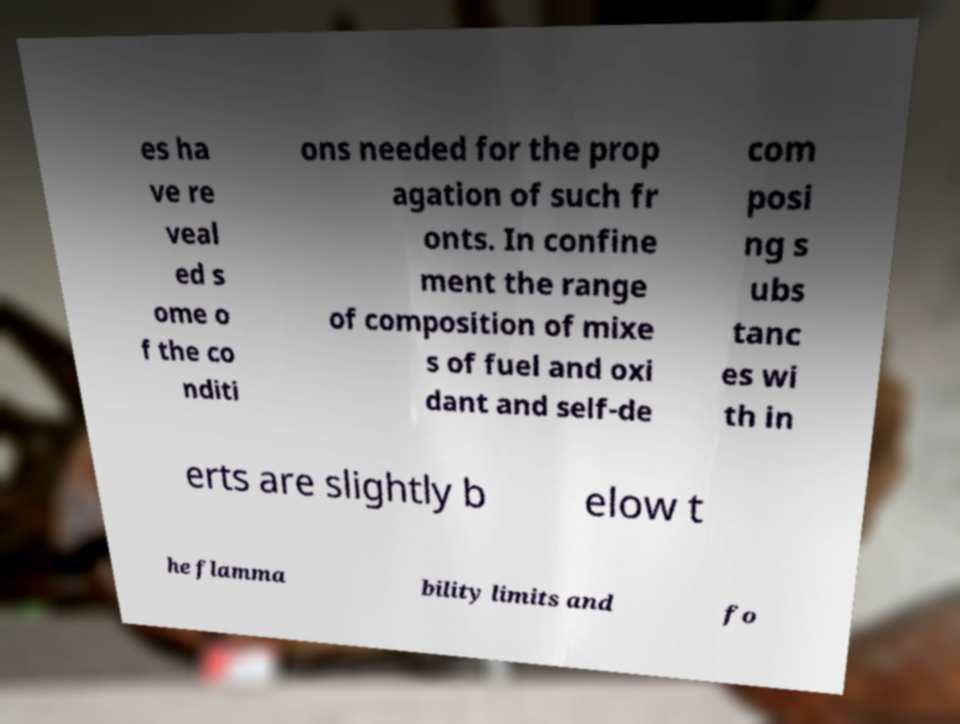For documentation purposes, I need the text within this image transcribed. Could you provide that? es ha ve re veal ed s ome o f the co nditi ons needed for the prop agation of such fr onts. In confine ment the range of composition of mixe s of fuel and oxi dant and self-de com posi ng s ubs tanc es wi th in erts are slightly b elow t he flamma bility limits and fo 